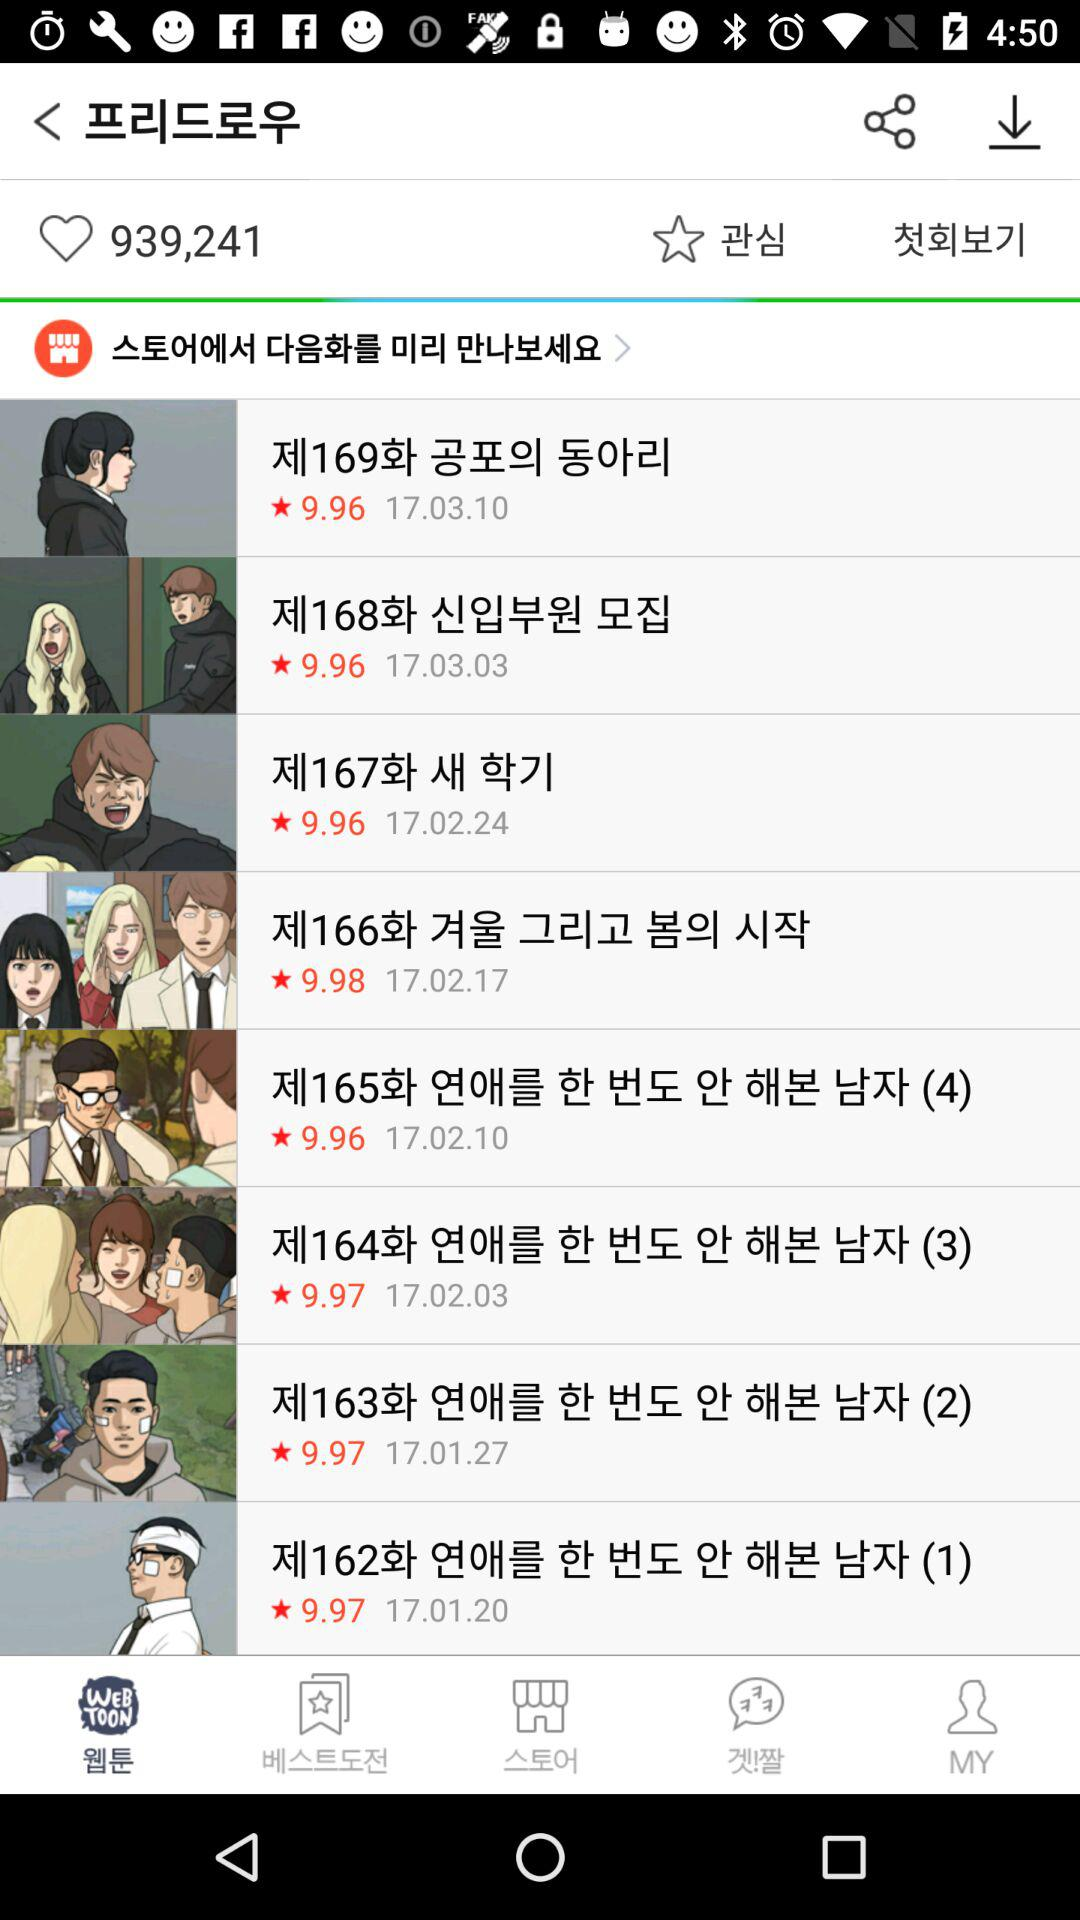How many more episodes have a rating of 9.96 than 9.97?
Answer the question using a single word or phrase. 1 